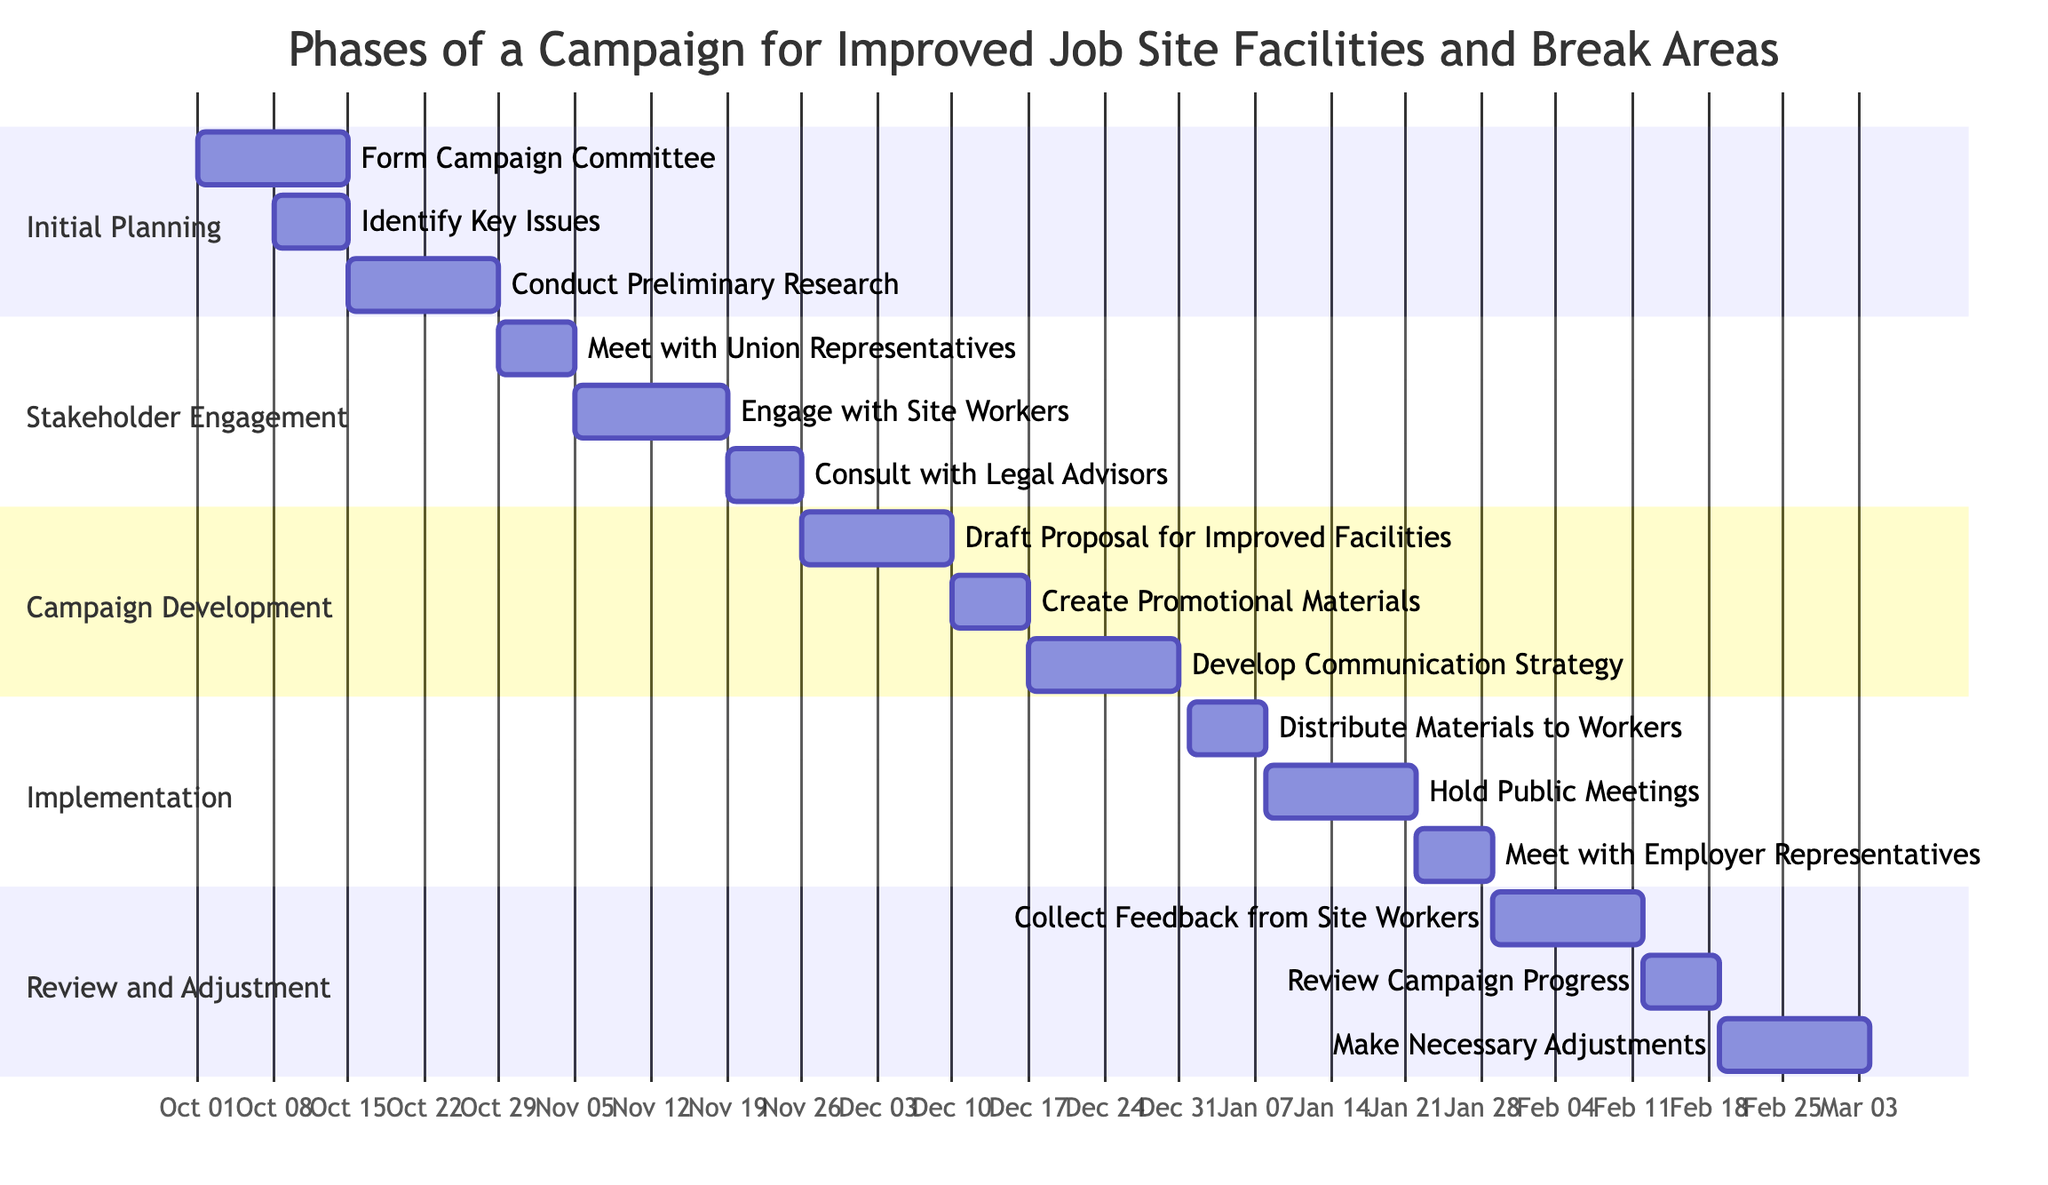What are the three phases of the campaign? The phases listed in the diagram are 'Initial Planning', 'Stakeholder Engagement', 'Campaign Development', 'Implementation', and 'Review and Adjustment'.  I will focus on the first three phases which are the first three sections.
Answer: Initial Planning, Stakeholder Engagement, Campaign Development Which task lasts the longest in the Initial Planning phase? In the Initial Planning phase, the tasks are 'Form Campaign Committee' for 2 weeks, 'Identify Key Issues' for 1 week, and 'Conduct Preliminary Research' for 2 weeks. The longest tasks are 'Form Campaign Committee' and 'Conduct Preliminary Research' both lasting 2 weeks.
Answer: Form Campaign Committee, Conduct Preliminary Research How many weeks is 'Engage with Site Workers'? The 'Engage with Site Workers' task in the Stakeholder Engagement phase is listed with a duration of 2 weeks.
Answer: 2 weeks What is the start date for the 'Develop Communication Strategy' task? The 'Develop Communication Strategy' task is scheduled to start on '2023-12-17' as indicated in the Campaign Development phase of the Gantt chart.
Answer: 2023-12-17 Which task follows 'Hold Public Meetings'? The task that follows 'Hold Public Meetings', which lasts for 2 weeks starting on '2024-01-08', is 'Meet with Employer Representatives' which starts on '2024-01-22'.
Answer: Meet with Employer Representatives What is the total duration of tasks in the Review and Adjustment phase? The tasks in the Review and Adjustment phase are 'Collect Feedback from Site Workers' for 2 weeks, 'Review Campaign Progress' for 1 week, and 'Make Necessary Adjustments' for 2 weeks. Adding these together gives a total duration of 2 + 1 + 2 = 5 weeks.
Answer: 5 weeks In which phase does the task 'Consult with Legal Advisors' occur? Looking at the sections in the diagram, 'Consult with Legal Advisors' is part of the 'Stakeholder Engagement' phase which also includes other tasks like 'Meet with Union Representatives' and 'Engage with Site Workers'.
Answer: Stakeholder Engagement How many total tasks are listed in the Campaign Development phase? The Campaign Development phase contains three tasks: 'Draft Proposal for Improved Facilities', 'Create Promotional Materials', and 'Develop Communication Strategy'. Therefore, there are a total of 3 tasks in this phase.
Answer: 3 tasks 